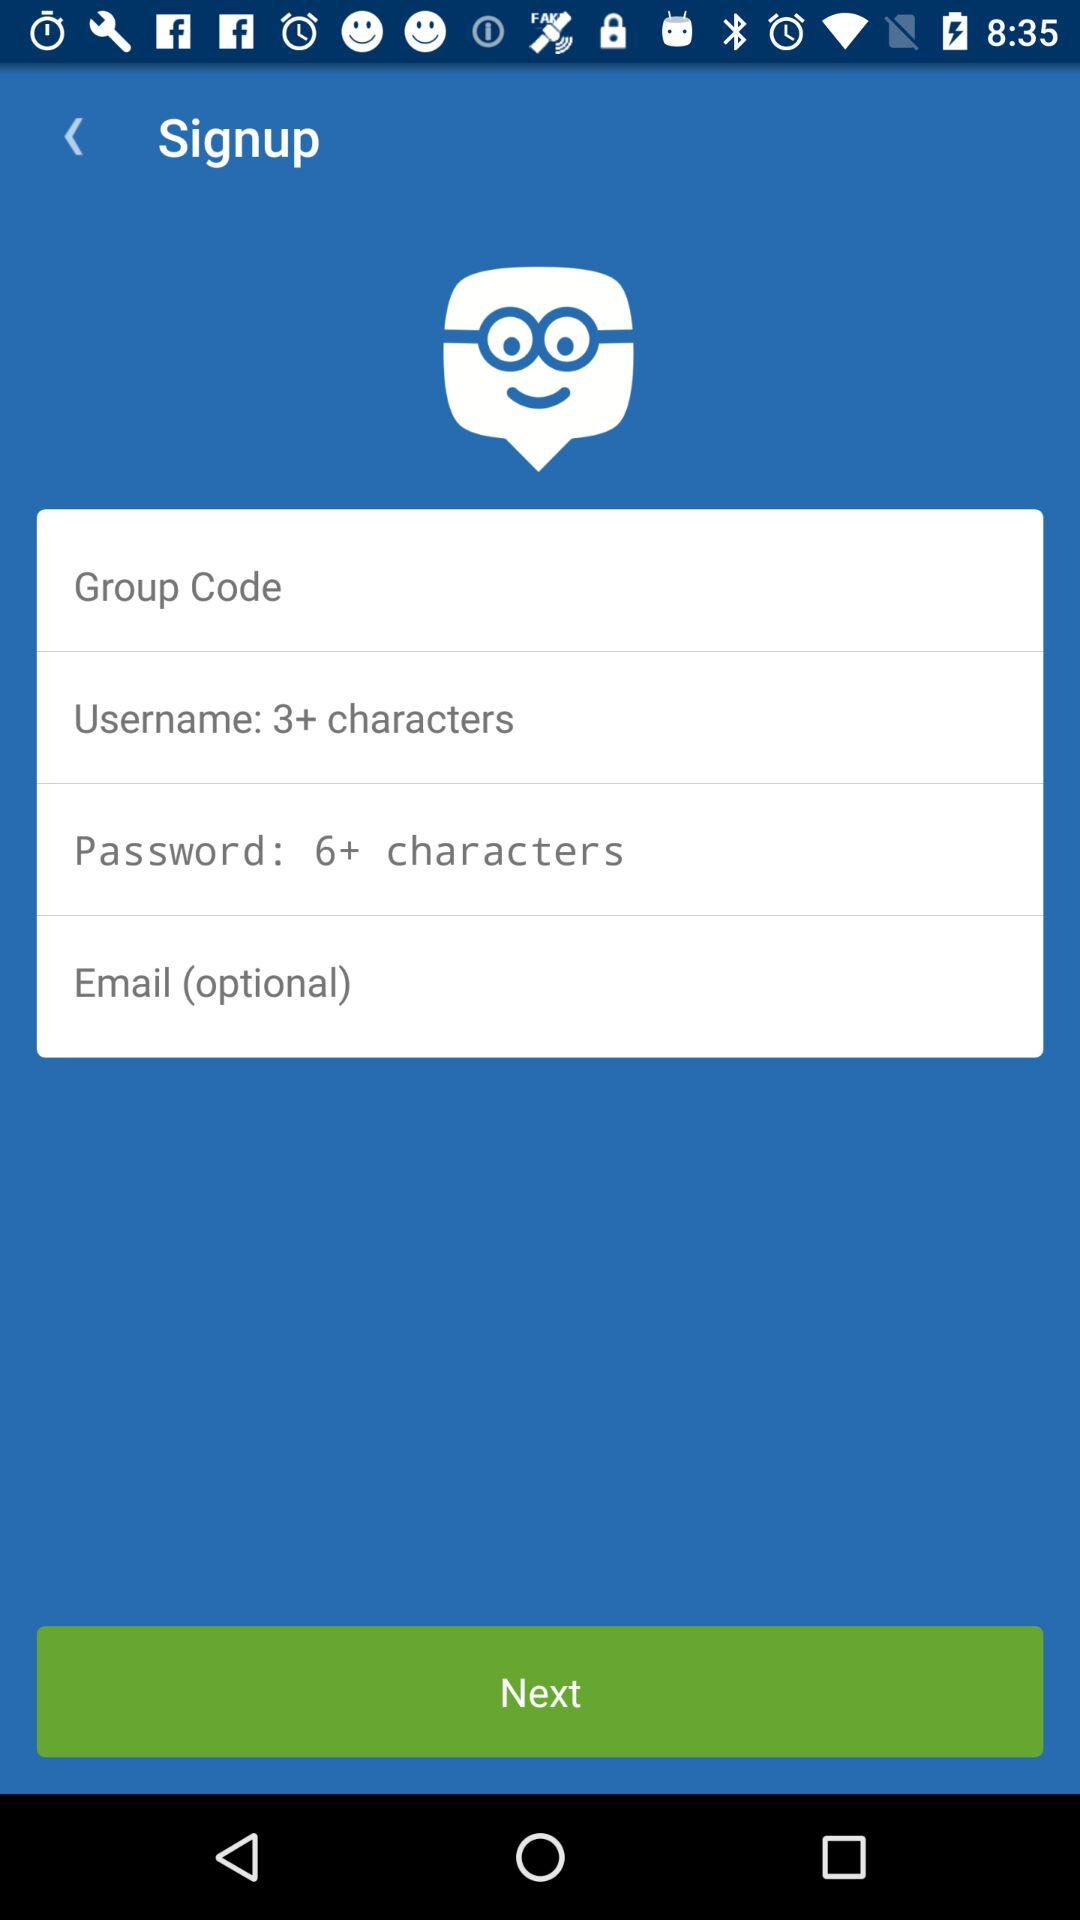How many characters are required in the password? There are more than 6 characters required in the password. 